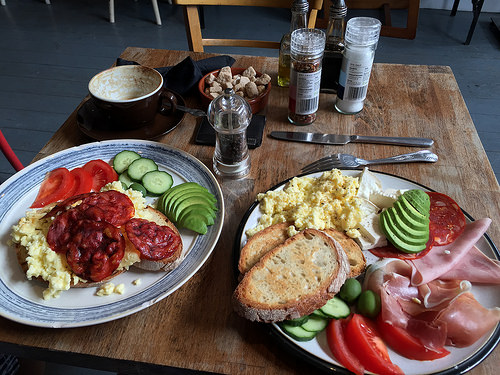<image>
Is the food on the plate? No. The food is not positioned on the plate. They may be near each other, but the food is not supported by or resting on top of the plate. Is there a fork in front of the knife? Yes. The fork is positioned in front of the knife, appearing closer to the camera viewpoint. 